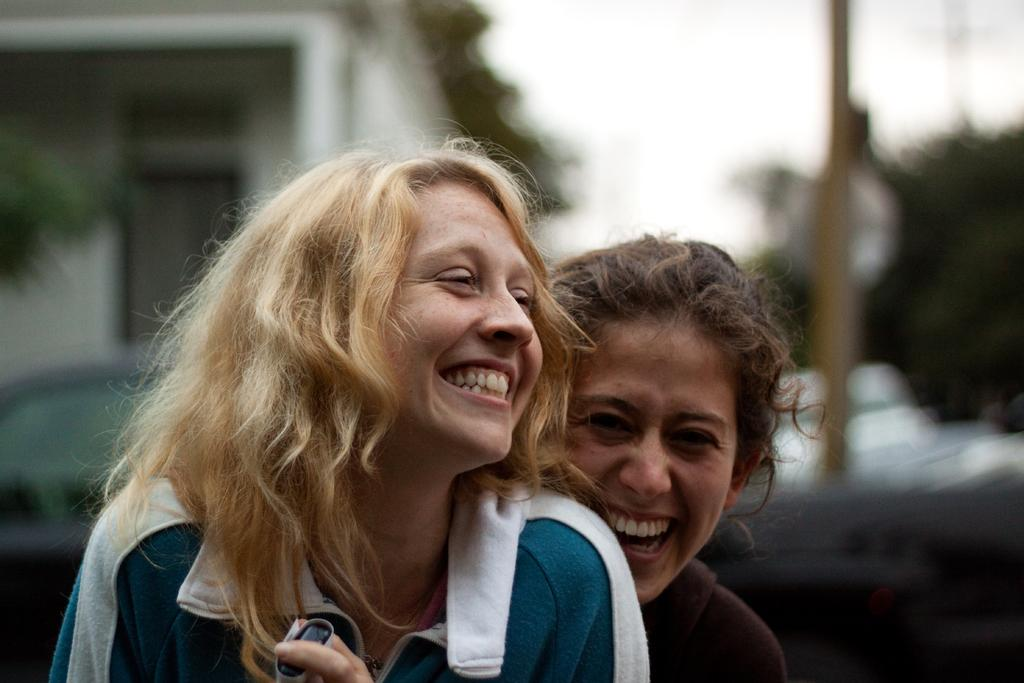How many people are in the image? There are two women in the image. What are the expressions on the women's faces? The women are smiling in the image. What can be seen on the left side of the image? There is a building on the left side of the image. What type of vegetation is visible in the background of the image? There appears to be a tree in the background of the image. How would you describe the background of the image? The background of the image is blurry. What type of ear is visible on the tree in the background of the image? There is no ear visible on the tree in the background of the image; it is a tree, not an animal with ears. 